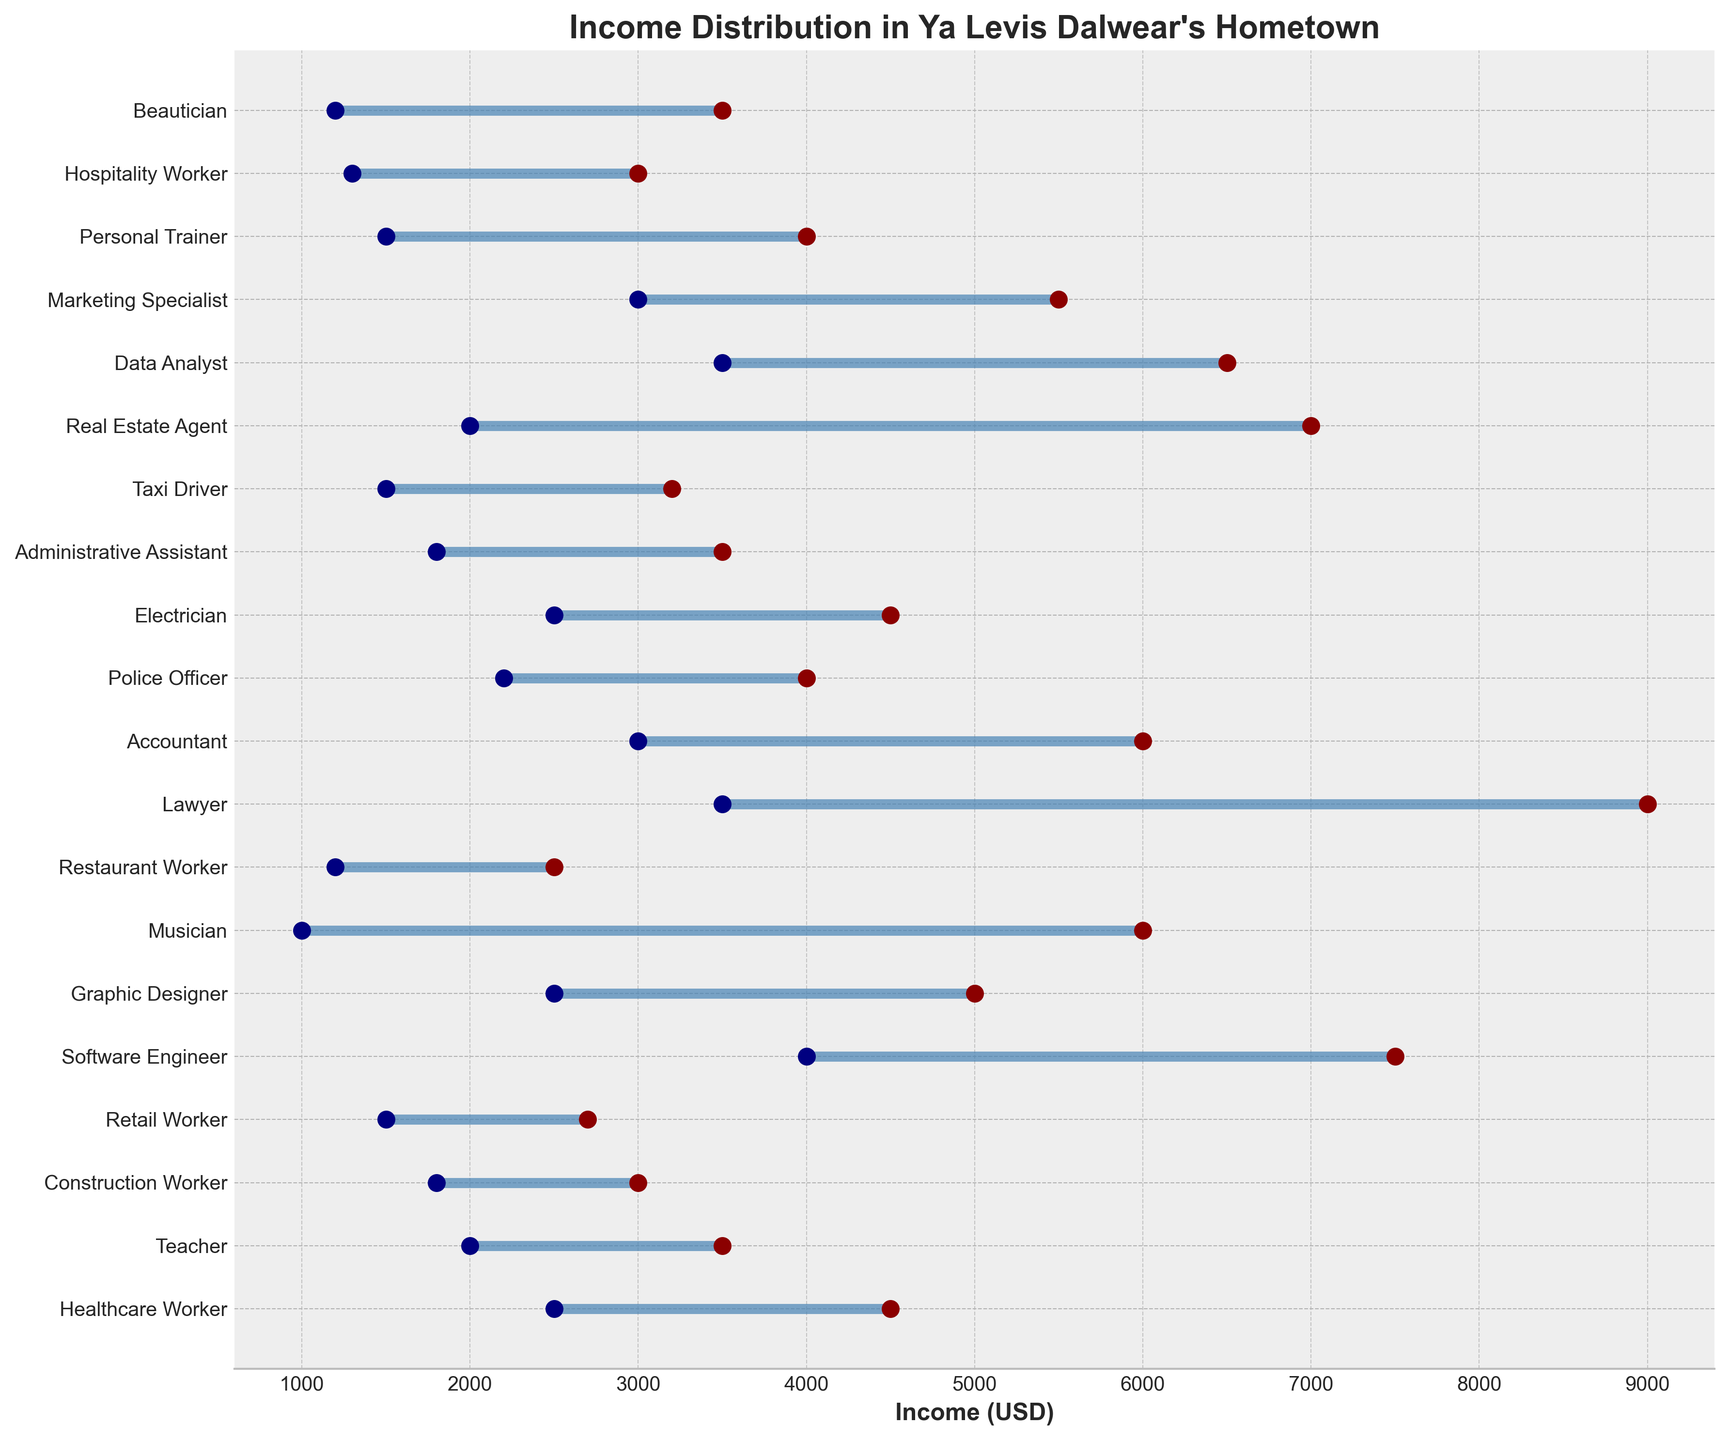What is the maximum income for Healthcare Workers? The maximum income is indicated by the top end of the horizontal line for Healthcare Workers.
Answer: 4500 What is the range of incomes for Teachers? The range is calculated by subtracting the minimum income from the maximum income for Teachers.
Answer: 1500 Which profession has the highest maximum income? Compare the maximum income values for all professions.
Answer: Lawyer Which profession has the smallest range of incomes? Calculate the range (max - min) for each profession and find the smallest one.
Answer: Construction Worker What is the average maximum income for Software Engineers, Lawyers, and Data Analysts? Add the maximum incomes for these professions and then divide by 3: (7500 + 9000 + 6500) / 3.
Answer: 7666.67 Do Musicians have a higher maximum income than Healthcare Workers? Compare the maximum income values for Musicians and Healthcare Workers.
Answer: Yes How many professions have a minimum income of 2500 or more? Count the number of professions where the minimum income is 2500 or more.
Answer: 4 What is the income range for Graphic Designers and how does it compare to that of Accountants? Calculate the income range for each: Graphic Designers: 5000 - 2500 = 2500, Accountants: 6000 - 3000 = 3000. Compare the two ranges.
Answer: Graphic Designers: 2500, Accountants: 3000 Is there any profession with both a minimum income below 2000 and a maximum income above 6000? Check all professions to see if any meets both conditions. The only possible candidate is Musician.
Answer: Yes, Musician Which profession has a wider income range, Real Estate Agents or Taxi Drivers? Calculate and compare the income ranges: Real Estate Agents: 7000 - 2000 = 5000, Taxi Drivers: 3200 - 1500 = 1700.
Answer: Real Estate Agents 